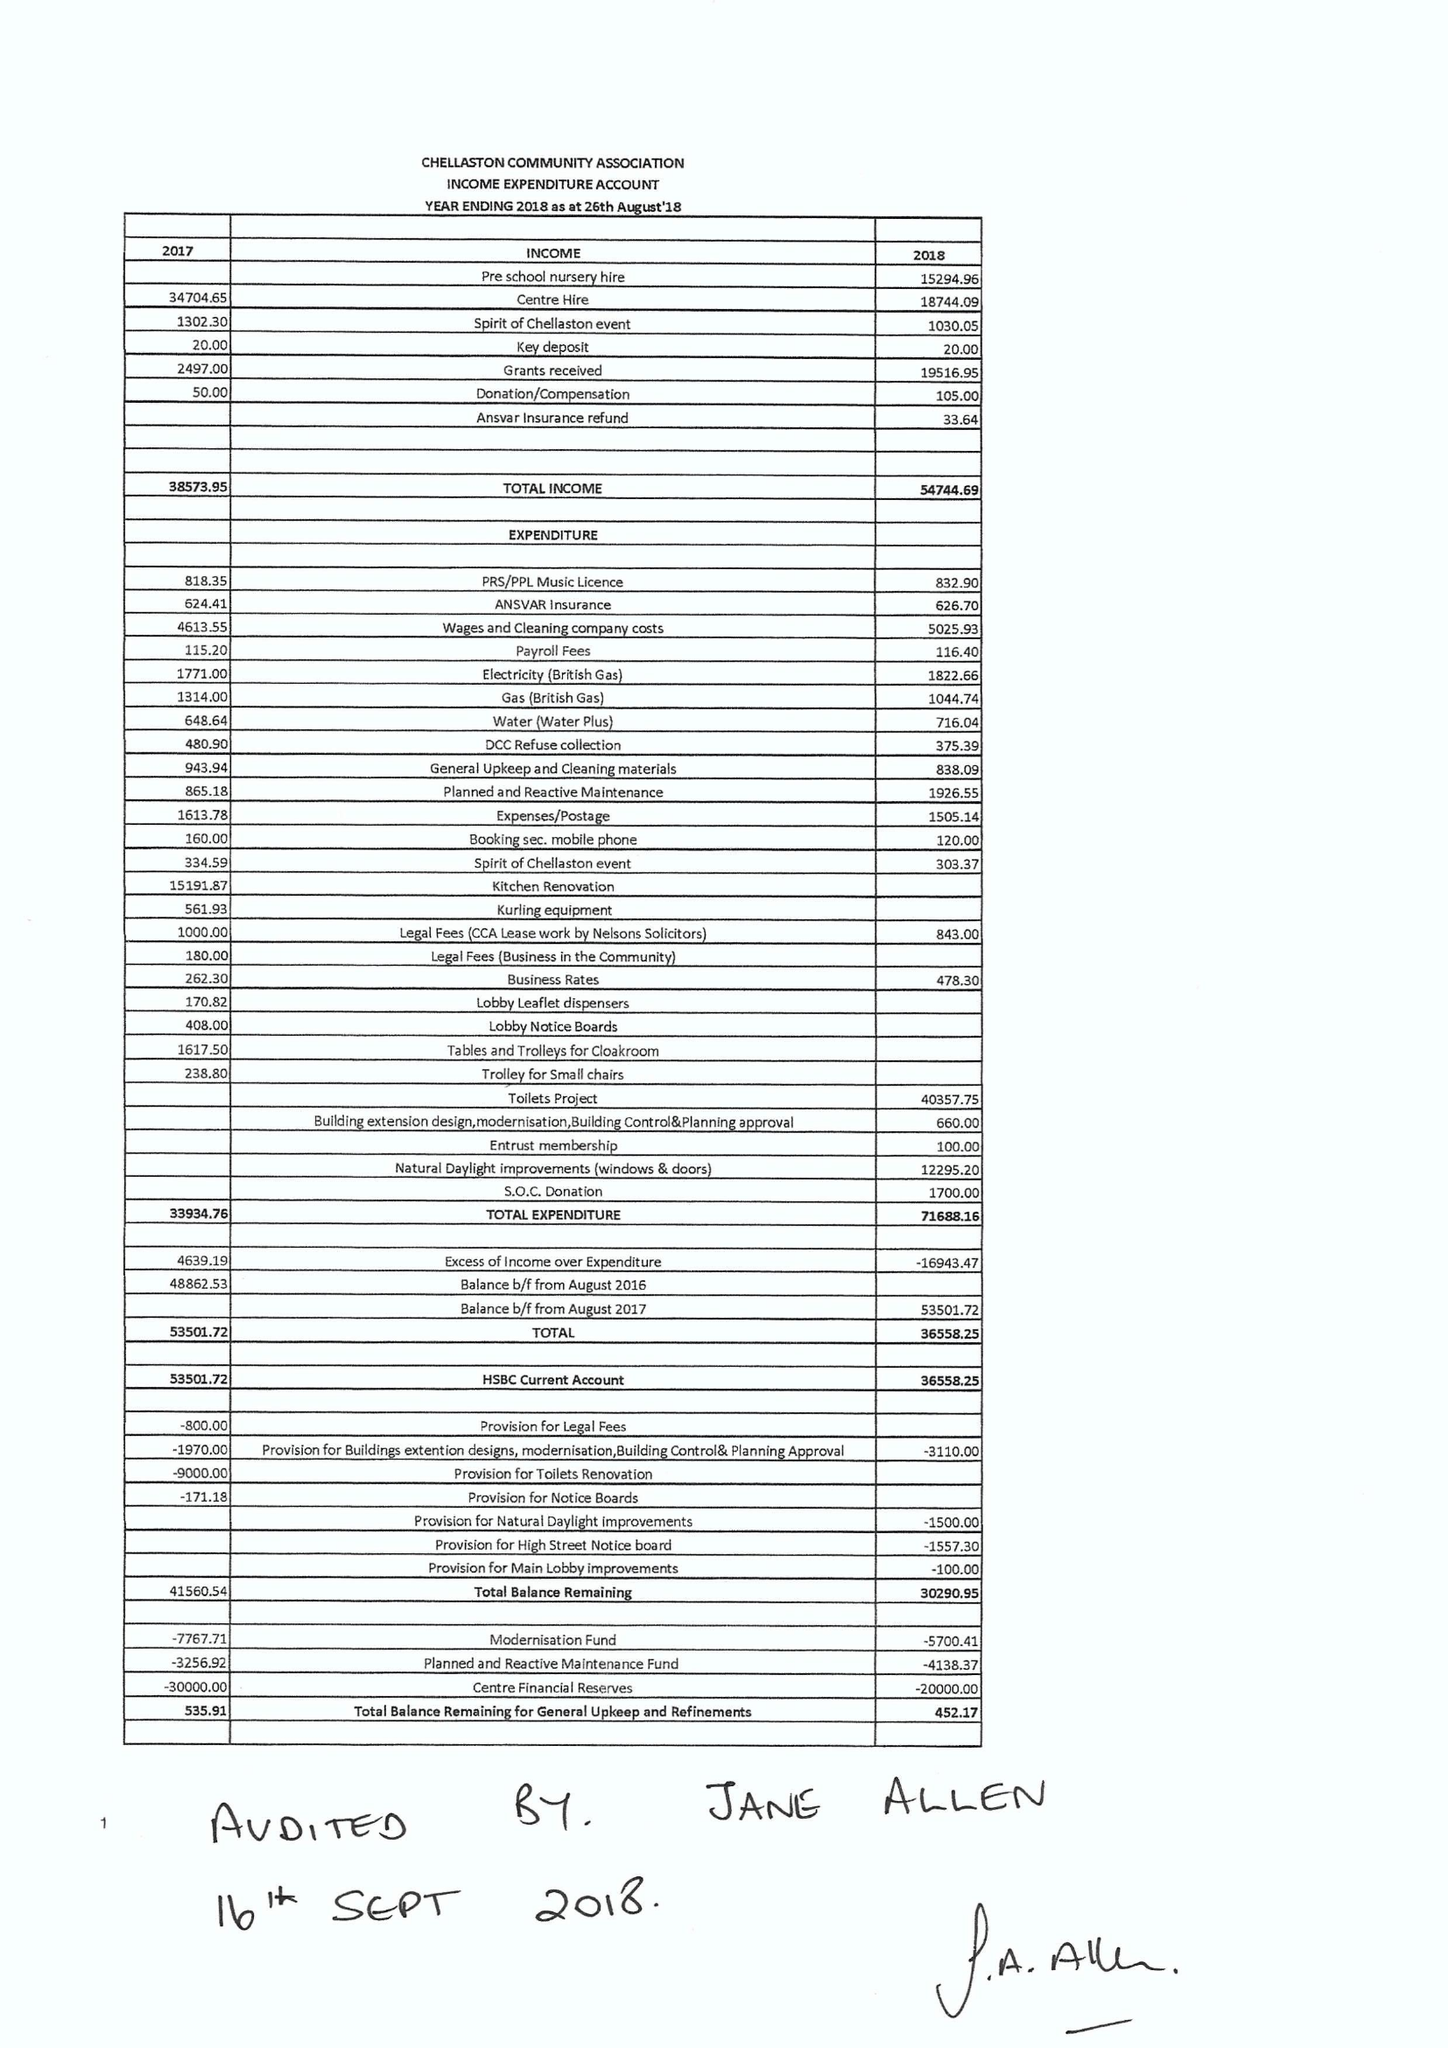What is the value for the address__post_town?
Answer the question using a single word or phrase. DERBY 